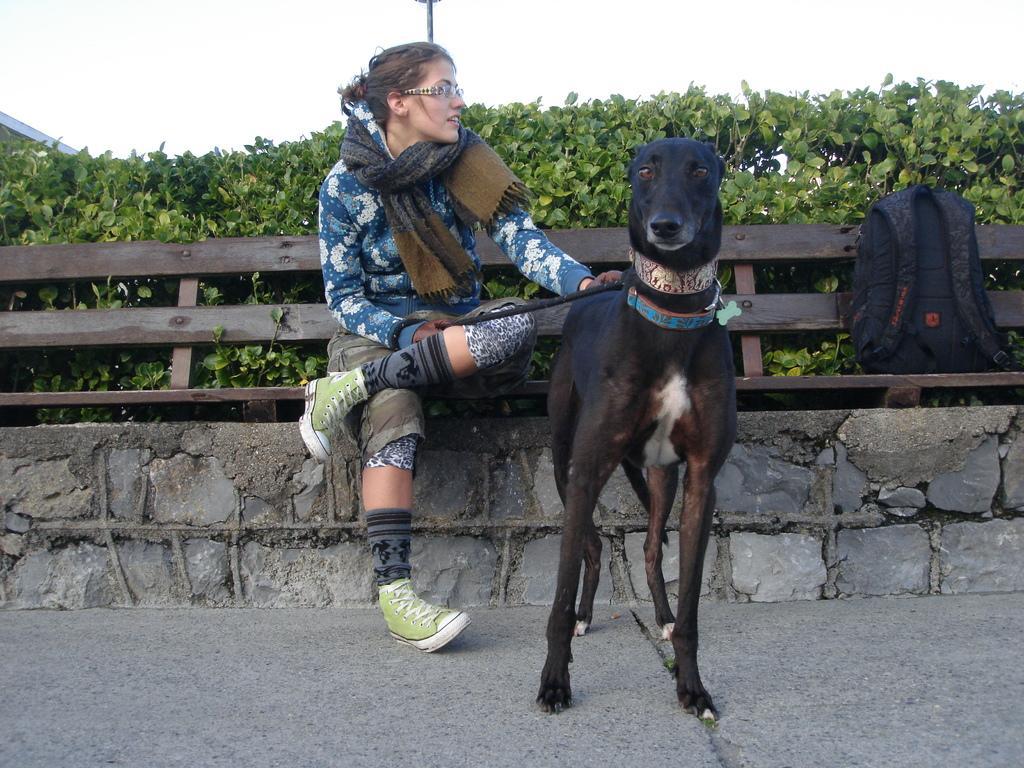In one or two sentences, can you explain what this image depicts? In this image I can see a dog, a girl is sitting on a bench and there is a bag on the right. There are plants and a pole at the back. 